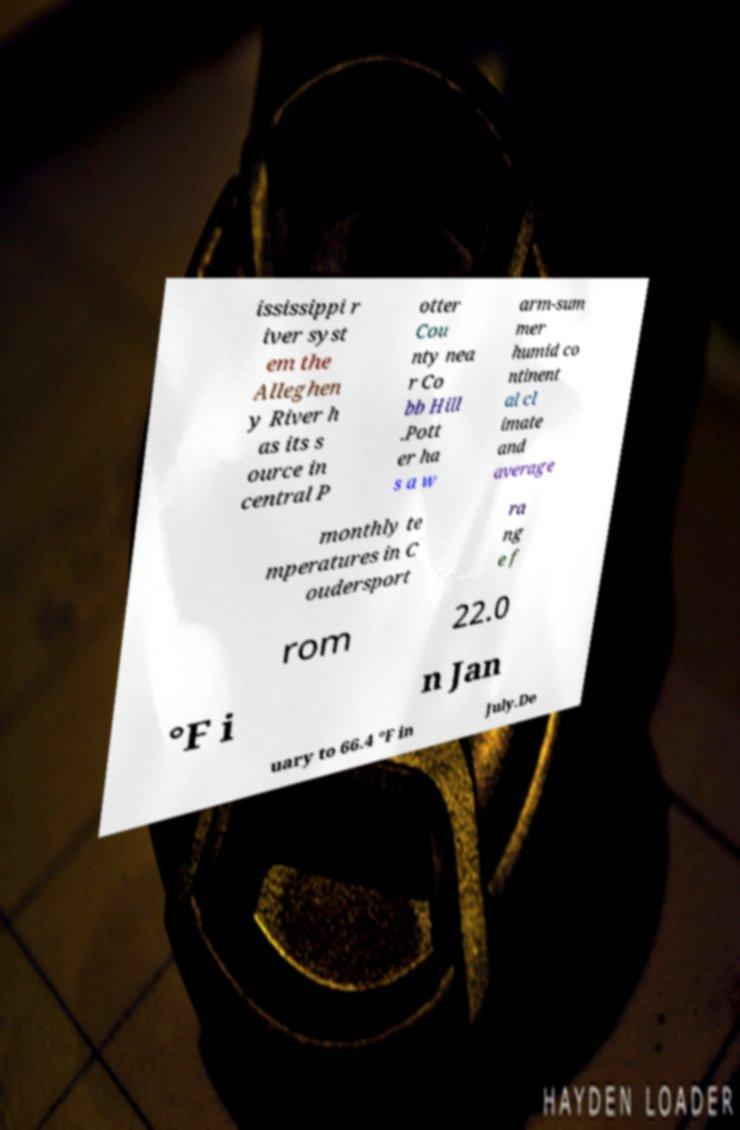I need the written content from this picture converted into text. Can you do that? ississippi r iver syst em the Alleghen y River h as its s ource in central P otter Cou nty nea r Co bb Hill .Pott er ha s a w arm-sum mer humid co ntinent al cl imate and average monthly te mperatures in C oudersport ra ng e f rom 22.0 °F i n Jan uary to 66.4 °F in July.De 